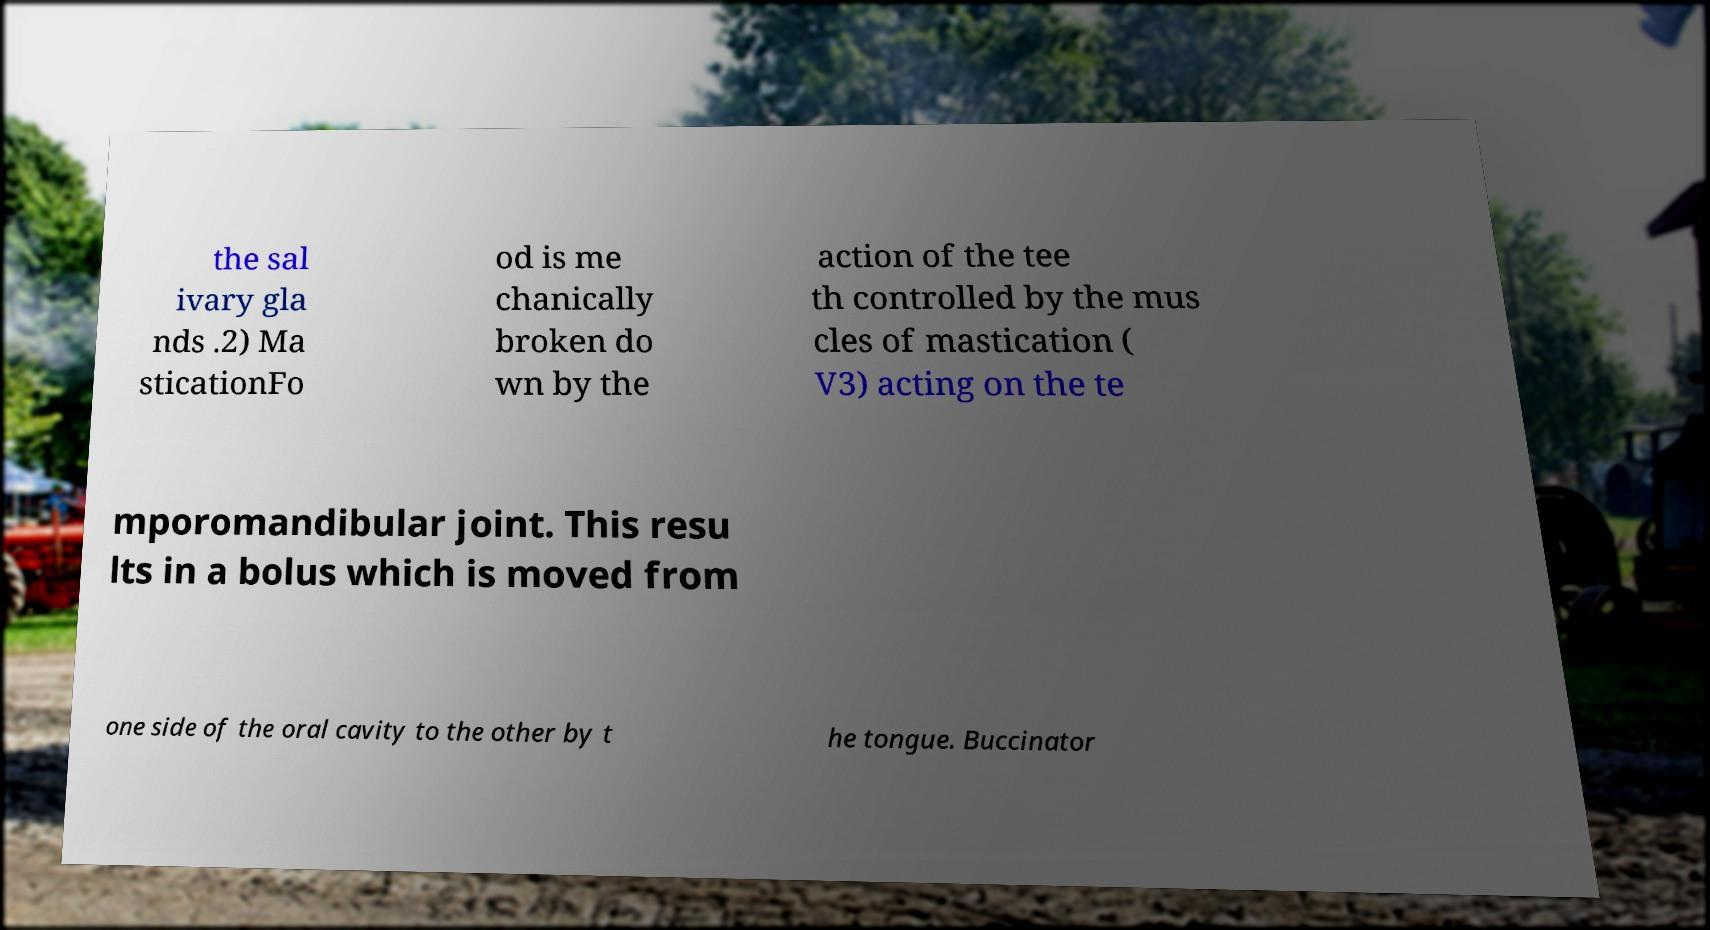Can you accurately transcribe the text from the provided image for me? the sal ivary gla nds .2) Ma sticationFo od is me chanically broken do wn by the action of the tee th controlled by the mus cles of mastication ( V3) acting on the te mporomandibular joint. This resu lts in a bolus which is moved from one side of the oral cavity to the other by t he tongue. Buccinator 